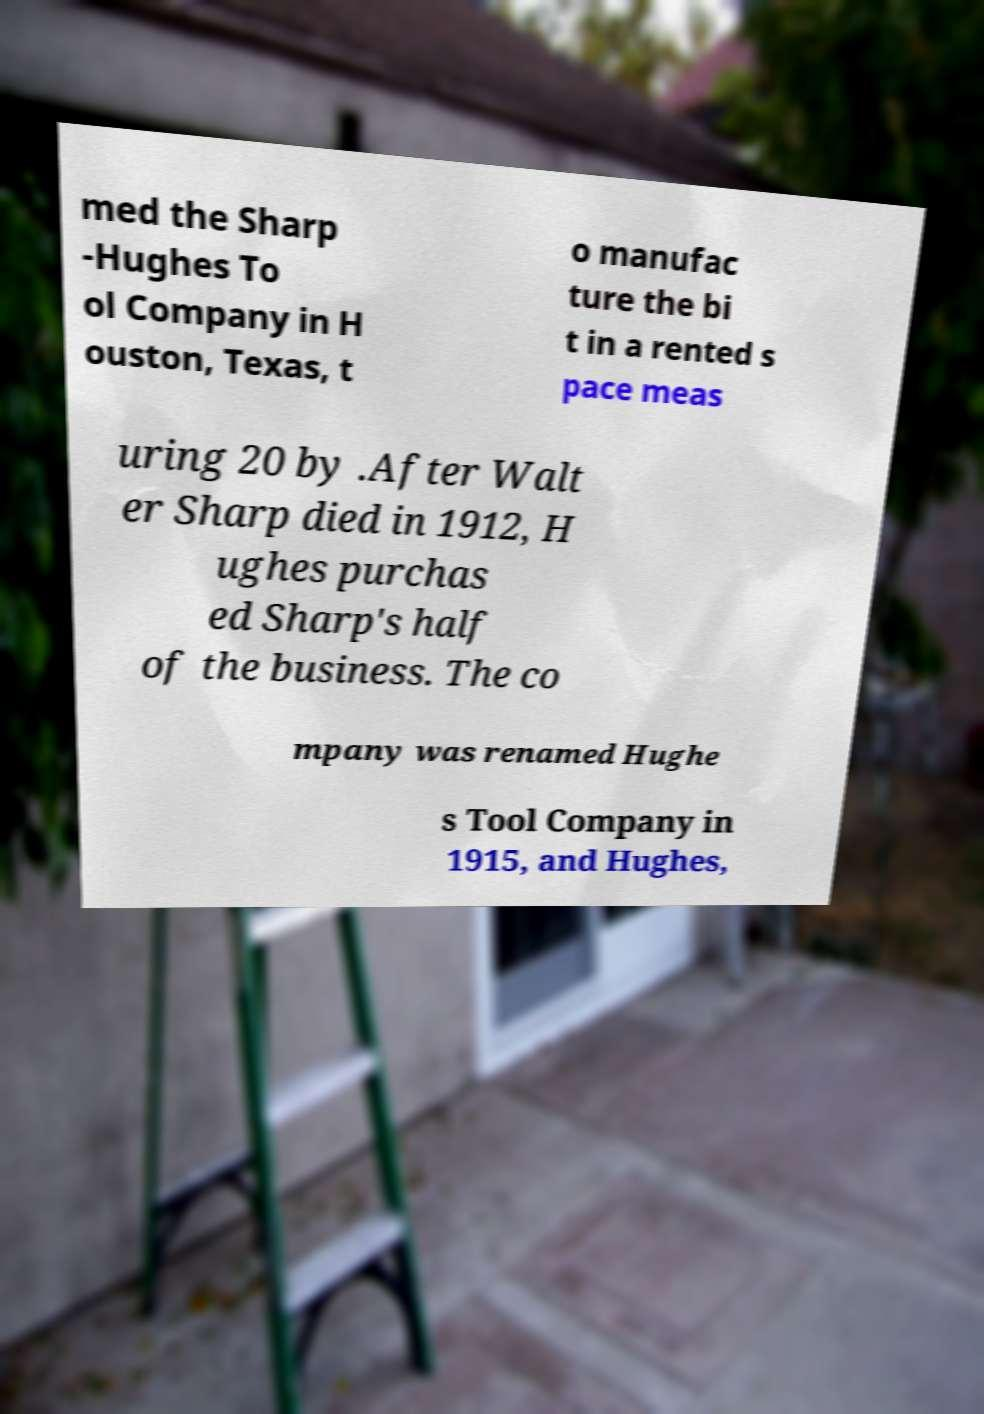For documentation purposes, I need the text within this image transcribed. Could you provide that? med the Sharp -Hughes To ol Company in H ouston, Texas, t o manufac ture the bi t in a rented s pace meas uring 20 by .After Walt er Sharp died in 1912, H ughes purchas ed Sharp's half of the business. The co mpany was renamed Hughe s Tool Company in 1915, and Hughes, 